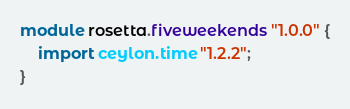Convert code to text. <code><loc_0><loc_0><loc_500><loc_500><_Ceylon_>module rosetta.fiveweekends "1.0.0" {
    import ceylon.time "1.2.2";
}
</code> 